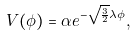Convert formula to latex. <formula><loc_0><loc_0><loc_500><loc_500>V ( \phi ) = \alpha e ^ { - \sqrt { \frac { 3 } { 2 } } \lambda \phi } ,</formula> 